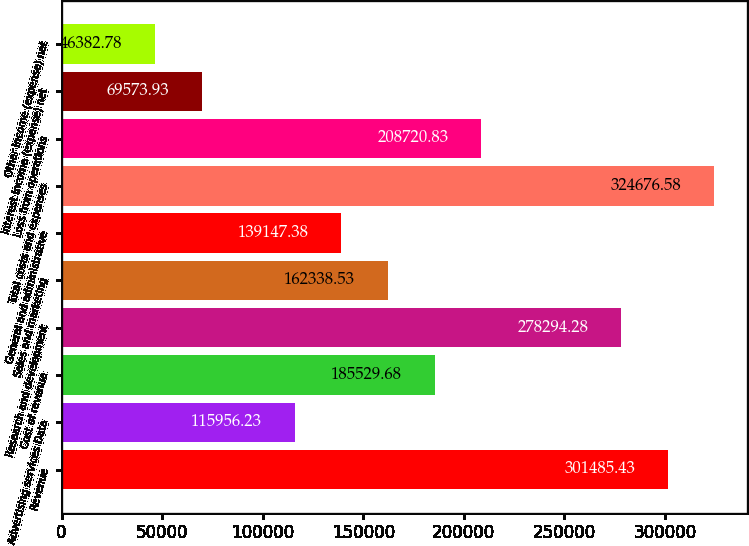Convert chart to OTSL. <chart><loc_0><loc_0><loc_500><loc_500><bar_chart><fcel>Revenue<fcel>Advertising services Data<fcel>Cost of revenue<fcel>Research and development<fcel>Sales and marketing<fcel>General and administrative<fcel>Total costs and expenses<fcel>Loss from operations<fcel>Interest income (expense) net<fcel>Other income (expense) net<nl><fcel>301485<fcel>115956<fcel>185530<fcel>278294<fcel>162339<fcel>139147<fcel>324677<fcel>208721<fcel>69573.9<fcel>46382.8<nl></chart> 